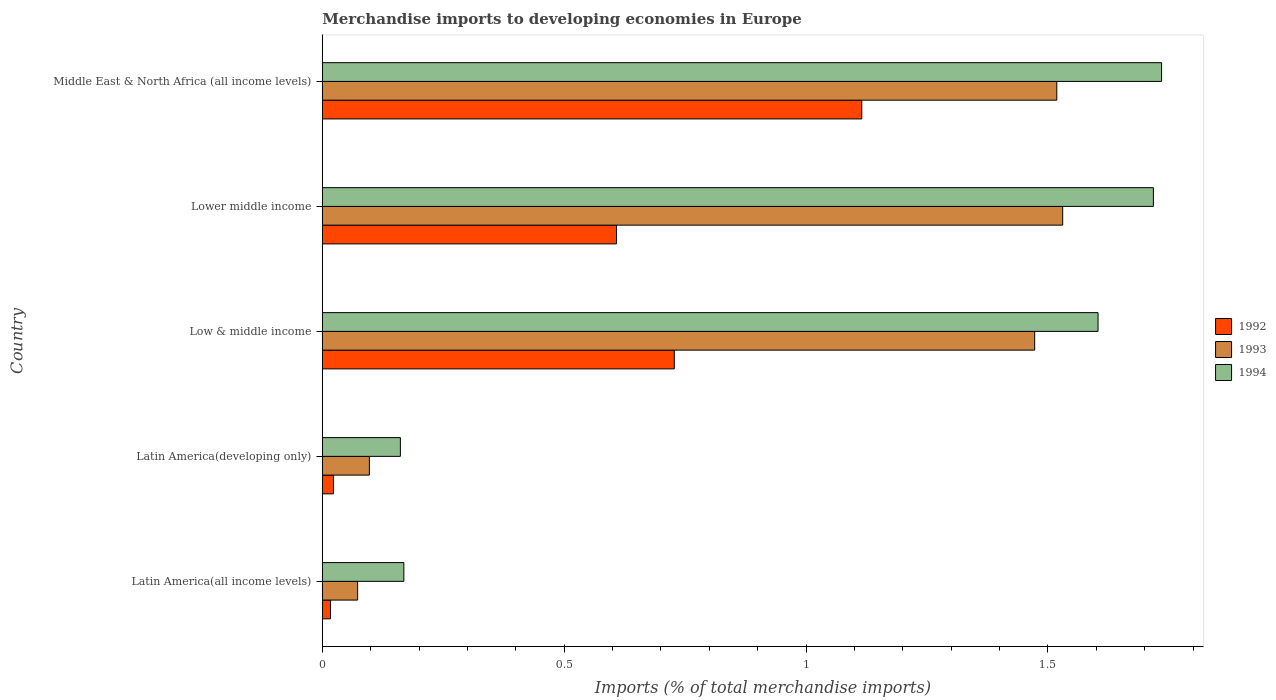How many groups of bars are there?
Ensure brevity in your answer.  5. How many bars are there on the 5th tick from the top?
Offer a terse response. 3. How many bars are there on the 1st tick from the bottom?
Make the answer very short. 3. What is the label of the 4th group of bars from the top?
Keep it short and to the point. Latin America(developing only). In how many cases, is the number of bars for a given country not equal to the number of legend labels?
Offer a very short reply. 0. What is the percentage total merchandise imports in 1994 in Low & middle income?
Give a very brief answer. 1.6. Across all countries, what is the maximum percentage total merchandise imports in 1994?
Provide a succinct answer. 1.74. Across all countries, what is the minimum percentage total merchandise imports in 1993?
Make the answer very short. 0.07. In which country was the percentage total merchandise imports in 1993 maximum?
Offer a terse response. Lower middle income. In which country was the percentage total merchandise imports in 1993 minimum?
Provide a succinct answer. Latin America(all income levels). What is the total percentage total merchandise imports in 1994 in the graph?
Give a very brief answer. 5.39. What is the difference between the percentage total merchandise imports in 1992 in Latin America(all income levels) and that in Lower middle income?
Your answer should be very brief. -0.59. What is the difference between the percentage total merchandise imports in 1994 in Latin America(all income levels) and the percentage total merchandise imports in 1993 in Latin America(developing only)?
Provide a short and direct response. 0.07. What is the average percentage total merchandise imports in 1993 per country?
Keep it short and to the point. 0.94. What is the difference between the percentage total merchandise imports in 1992 and percentage total merchandise imports in 1994 in Latin America(developing only)?
Ensure brevity in your answer.  -0.14. In how many countries, is the percentage total merchandise imports in 1993 greater than 0.6 %?
Provide a short and direct response. 3. What is the ratio of the percentage total merchandise imports in 1994 in Latin America(all income levels) to that in Lower middle income?
Keep it short and to the point. 0.1. What is the difference between the highest and the second highest percentage total merchandise imports in 1993?
Offer a very short reply. 0.01. What is the difference between the highest and the lowest percentage total merchandise imports in 1993?
Provide a succinct answer. 1.46. Is the sum of the percentage total merchandise imports in 1993 in Latin America(all income levels) and Middle East & North Africa (all income levels) greater than the maximum percentage total merchandise imports in 1994 across all countries?
Your response must be concise. No. Is it the case that in every country, the sum of the percentage total merchandise imports in 1993 and percentage total merchandise imports in 1992 is greater than the percentage total merchandise imports in 1994?
Give a very brief answer. No. Are all the bars in the graph horizontal?
Keep it short and to the point. Yes. How many countries are there in the graph?
Provide a succinct answer. 5. What is the difference between two consecutive major ticks on the X-axis?
Your response must be concise. 0.5. Does the graph contain any zero values?
Give a very brief answer. No. Does the graph contain grids?
Ensure brevity in your answer.  No. Where does the legend appear in the graph?
Give a very brief answer. Center right. How are the legend labels stacked?
Give a very brief answer. Vertical. What is the title of the graph?
Make the answer very short. Merchandise imports to developing economies in Europe. Does "2012" appear as one of the legend labels in the graph?
Your response must be concise. No. What is the label or title of the X-axis?
Your answer should be very brief. Imports (% of total merchandise imports). What is the label or title of the Y-axis?
Make the answer very short. Country. What is the Imports (% of total merchandise imports) in 1992 in Latin America(all income levels)?
Your answer should be compact. 0.02. What is the Imports (% of total merchandise imports) in 1993 in Latin America(all income levels)?
Your answer should be very brief. 0.07. What is the Imports (% of total merchandise imports) in 1994 in Latin America(all income levels)?
Provide a succinct answer. 0.17. What is the Imports (% of total merchandise imports) in 1992 in Latin America(developing only)?
Keep it short and to the point. 0.02. What is the Imports (% of total merchandise imports) of 1993 in Latin America(developing only)?
Provide a short and direct response. 0.1. What is the Imports (% of total merchandise imports) in 1994 in Latin America(developing only)?
Ensure brevity in your answer.  0.16. What is the Imports (% of total merchandise imports) in 1992 in Low & middle income?
Make the answer very short. 0.73. What is the Imports (% of total merchandise imports) of 1993 in Low & middle income?
Your answer should be very brief. 1.47. What is the Imports (% of total merchandise imports) of 1994 in Low & middle income?
Ensure brevity in your answer.  1.6. What is the Imports (% of total merchandise imports) of 1992 in Lower middle income?
Provide a succinct answer. 0.61. What is the Imports (% of total merchandise imports) in 1993 in Lower middle income?
Your answer should be compact. 1.53. What is the Imports (% of total merchandise imports) of 1994 in Lower middle income?
Keep it short and to the point. 1.72. What is the Imports (% of total merchandise imports) of 1992 in Middle East & North Africa (all income levels)?
Keep it short and to the point. 1.12. What is the Imports (% of total merchandise imports) in 1993 in Middle East & North Africa (all income levels)?
Give a very brief answer. 1.52. What is the Imports (% of total merchandise imports) of 1994 in Middle East & North Africa (all income levels)?
Provide a short and direct response. 1.74. Across all countries, what is the maximum Imports (% of total merchandise imports) in 1992?
Your answer should be compact. 1.12. Across all countries, what is the maximum Imports (% of total merchandise imports) in 1993?
Your response must be concise. 1.53. Across all countries, what is the maximum Imports (% of total merchandise imports) of 1994?
Provide a short and direct response. 1.74. Across all countries, what is the minimum Imports (% of total merchandise imports) in 1992?
Keep it short and to the point. 0.02. Across all countries, what is the minimum Imports (% of total merchandise imports) in 1993?
Give a very brief answer. 0.07. Across all countries, what is the minimum Imports (% of total merchandise imports) of 1994?
Offer a very short reply. 0.16. What is the total Imports (% of total merchandise imports) of 1992 in the graph?
Your answer should be very brief. 2.49. What is the total Imports (% of total merchandise imports) in 1993 in the graph?
Keep it short and to the point. 4.69. What is the total Imports (% of total merchandise imports) in 1994 in the graph?
Provide a succinct answer. 5.39. What is the difference between the Imports (% of total merchandise imports) in 1992 in Latin America(all income levels) and that in Latin America(developing only)?
Offer a very short reply. -0.01. What is the difference between the Imports (% of total merchandise imports) in 1993 in Latin America(all income levels) and that in Latin America(developing only)?
Offer a very short reply. -0.02. What is the difference between the Imports (% of total merchandise imports) in 1994 in Latin America(all income levels) and that in Latin America(developing only)?
Your response must be concise. 0.01. What is the difference between the Imports (% of total merchandise imports) in 1992 in Latin America(all income levels) and that in Low & middle income?
Your answer should be compact. -0.71. What is the difference between the Imports (% of total merchandise imports) in 1993 in Latin America(all income levels) and that in Low & middle income?
Provide a short and direct response. -1.4. What is the difference between the Imports (% of total merchandise imports) in 1994 in Latin America(all income levels) and that in Low & middle income?
Your response must be concise. -1.44. What is the difference between the Imports (% of total merchandise imports) of 1992 in Latin America(all income levels) and that in Lower middle income?
Your answer should be very brief. -0.59. What is the difference between the Imports (% of total merchandise imports) of 1993 in Latin America(all income levels) and that in Lower middle income?
Your answer should be compact. -1.46. What is the difference between the Imports (% of total merchandise imports) of 1994 in Latin America(all income levels) and that in Lower middle income?
Ensure brevity in your answer.  -1.55. What is the difference between the Imports (% of total merchandise imports) of 1992 in Latin America(all income levels) and that in Middle East & North Africa (all income levels)?
Provide a short and direct response. -1.1. What is the difference between the Imports (% of total merchandise imports) in 1993 in Latin America(all income levels) and that in Middle East & North Africa (all income levels)?
Offer a terse response. -1.45. What is the difference between the Imports (% of total merchandise imports) in 1994 in Latin America(all income levels) and that in Middle East & North Africa (all income levels)?
Give a very brief answer. -1.57. What is the difference between the Imports (% of total merchandise imports) in 1992 in Latin America(developing only) and that in Low & middle income?
Provide a succinct answer. -0.7. What is the difference between the Imports (% of total merchandise imports) in 1993 in Latin America(developing only) and that in Low & middle income?
Provide a short and direct response. -1.38. What is the difference between the Imports (% of total merchandise imports) in 1994 in Latin America(developing only) and that in Low & middle income?
Offer a terse response. -1.44. What is the difference between the Imports (% of total merchandise imports) in 1992 in Latin America(developing only) and that in Lower middle income?
Offer a terse response. -0.59. What is the difference between the Imports (% of total merchandise imports) of 1993 in Latin America(developing only) and that in Lower middle income?
Your answer should be very brief. -1.43. What is the difference between the Imports (% of total merchandise imports) in 1994 in Latin America(developing only) and that in Lower middle income?
Keep it short and to the point. -1.56. What is the difference between the Imports (% of total merchandise imports) of 1992 in Latin America(developing only) and that in Middle East & North Africa (all income levels)?
Your answer should be very brief. -1.09. What is the difference between the Imports (% of total merchandise imports) of 1993 in Latin America(developing only) and that in Middle East & North Africa (all income levels)?
Keep it short and to the point. -1.42. What is the difference between the Imports (% of total merchandise imports) in 1994 in Latin America(developing only) and that in Middle East & North Africa (all income levels)?
Keep it short and to the point. -1.57. What is the difference between the Imports (% of total merchandise imports) of 1992 in Low & middle income and that in Lower middle income?
Your answer should be very brief. 0.12. What is the difference between the Imports (% of total merchandise imports) of 1993 in Low & middle income and that in Lower middle income?
Keep it short and to the point. -0.06. What is the difference between the Imports (% of total merchandise imports) in 1994 in Low & middle income and that in Lower middle income?
Offer a terse response. -0.11. What is the difference between the Imports (% of total merchandise imports) of 1992 in Low & middle income and that in Middle East & North Africa (all income levels)?
Make the answer very short. -0.39. What is the difference between the Imports (% of total merchandise imports) of 1993 in Low & middle income and that in Middle East & North Africa (all income levels)?
Offer a terse response. -0.05. What is the difference between the Imports (% of total merchandise imports) in 1994 in Low & middle income and that in Middle East & North Africa (all income levels)?
Provide a succinct answer. -0.13. What is the difference between the Imports (% of total merchandise imports) of 1992 in Lower middle income and that in Middle East & North Africa (all income levels)?
Keep it short and to the point. -0.51. What is the difference between the Imports (% of total merchandise imports) of 1993 in Lower middle income and that in Middle East & North Africa (all income levels)?
Offer a terse response. 0.01. What is the difference between the Imports (% of total merchandise imports) of 1994 in Lower middle income and that in Middle East & North Africa (all income levels)?
Make the answer very short. -0.02. What is the difference between the Imports (% of total merchandise imports) of 1992 in Latin America(all income levels) and the Imports (% of total merchandise imports) of 1993 in Latin America(developing only)?
Give a very brief answer. -0.08. What is the difference between the Imports (% of total merchandise imports) in 1992 in Latin America(all income levels) and the Imports (% of total merchandise imports) in 1994 in Latin America(developing only)?
Your answer should be compact. -0.14. What is the difference between the Imports (% of total merchandise imports) of 1993 in Latin America(all income levels) and the Imports (% of total merchandise imports) of 1994 in Latin America(developing only)?
Provide a succinct answer. -0.09. What is the difference between the Imports (% of total merchandise imports) in 1992 in Latin America(all income levels) and the Imports (% of total merchandise imports) in 1993 in Low & middle income?
Your answer should be very brief. -1.46. What is the difference between the Imports (% of total merchandise imports) of 1992 in Latin America(all income levels) and the Imports (% of total merchandise imports) of 1994 in Low & middle income?
Provide a succinct answer. -1.59. What is the difference between the Imports (% of total merchandise imports) of 1993 in Latin America(all income levels) and the Imports (% of total merchandise imports) of 1994 in Low & middle income?
Offer a very short reply. -1.53. What is the difference between the Imports (% of total merchandise imports) in 1992 in Latin America(all income levels) and the Imports (% of total merchandise imports) in 1993 in Lower middle income?
Your answer should be compact. -1.51. What is the difference between the Imports (% of total merchandise imports) in 1992 in Latin America(all income levels) and the Imports (% of total merchandise imports) in 1994 in Lower middle income?
Your response must be concise. -1.7. What is the difference between the Imports (% of total merchandise imports) in 1993 in Latin America(all income levels) and the Imports (% of total merchandise imports) in 1994 in Lower middle income?
Offer a very short reply. -1.65. What is the difference between the Imports (% of total merchandise imports) of 1992 in Latin America(all income levels) and the Imports (% of total merchandise imports) of 1993 in Middle East & North Africa (all income levels)?
Give a very brief answer. -1.5. What is the difference between the Imports (% of total merchandise imports) in 1992 in Latin America(all income levels) and the Imports (% of total merchandise imports) in 1994 in Middle East & North Africa (all income levels)?
Your response must be concise. -1.72. What is the difference between the Imports (% of total merchandise imports) of 1993 in Latin America(all income levels) and the Imports (% of total merchandise imports) of 1994 in Middle East & North Africa (all income levels)?
Offer a very short reply. -1.66. What is the difference between the Imports (% of total merchandise imports) in 1992 in Latin America(developing only) and the Imports (% of total merchandise imports) in 1993 in Low & middle income?
Your answer should be very brief. -1.45. What is the difference between the Imports (% of total merchandise imports) of 1992 in Latin America(developing only) and the Imports (% of total merchandise imports) of 1994 in Low & middle income?
Your answer should be very brief. -1.58. What is the difference between the Imports (% of total merchandise imports) of 1993 in Latin America(developing only) and the Imports (% of total merchandise imports) of 1994 in Low & middle income?
Ensure brevity in your answer.  -1.51. What is the difference between the Imports (% of total merchandise imports) in 1992 in Latin America(developing only) and the Imports (% of total merchandise imports) in 1993 in Lower middle income?
Keep it short and to the point. -1.51. What is the difference between the Imports (% of total merchandise imports) of 1992 in Latin America(developing only) and the Imports (% of total merchandise imports) of 1994 in Lower middle income?
Provide a succinct answer. -1.7. What is the difference between the Imports (% of total merchandise imports) of 1993 in Latin America(developing only) and the Imports (% of total merchandise imports) of 1994 in Lower middle income?
Your answer should be very brief. -1.62. What is the difference between the Imports (% of total merchandise imports) in 1992 in Latin America(developing only) and the Imports (% of total merchandise imports) in 1993 in Middle East & North Africa (all income levels)?
Your answer should be compact. -1.5. What is the difference between the Imports (% of total merchandise imports) in 1992 in Latin America(developing only) and the Imports (% of total merchandise imports) in 1994 in Middle East & North Africa (all income levels)?
Provide a succinct answer. -1.71. What is the difference between the Imports (% of total merchandise imports) of 1993 in Latin America(developing only) and the Imports (% of total merchandise imports) of 1994 in Middle East & North Africa (all income levels)?
Keep it short and to the point. -1.64. What is the difference between the Imports (% of total merchandise imports) of 1992 in Low & middle income and the Imports (% of total merchandise imports) of 1993 in Lower middle income?
Your answer should be very brief. -0.8. What is the difference between the Imports (% of total merchandise imports) of 1992 in Low & middle income and the Imports (% of total merchandise imports) of 1994 in Lower middle income?
Your answer should be very brief. -0.99. What is the difference between the Imports (% of total merchandise imports) in 1993 in Low & middle income and the Imports (% of total merchandise imports) in 1994 in Lower middle income?
Offer a very short reply. -0.25. What is the difference between the Imports (% of total merchandise imports) in 1992 in Low & middle income and the Imports (% of total merchandise imports) in 1993 in Middle East & North Africa (all income levels)?
Offer a terse response. -0.79. What is the difference between the Imports (% of total merchandise imports) of 1992 in Low & middle income and the Imports (% of total merchandise imports) of 1994 in Middle East & North Africa (all income levels)?
Offer a terse response. -1.01. What is the difference between the Imports (% of total merchandise imports) in 1993 in Low & middle income and the Imports (% of total merchandise imports) in 1994 in Middle East & North Africa (all income levels)?
Give a very brief answer. -0.26. What is the difference between the Imports (% of total merchandise imports) of 1992 in Lower middle income and the Imports (% of total merchandise imports) of 1993 in Middle East & North Africa (all income levels)?
Your response must be concise. -0.91. What is the difference between the Imports (% of total merchandise imports) of 1992 in Lower middle income and the Imports (% of total merchandise imports) of 1994 in Middle East & North Africa (all income levels)?
Offer a very short reply. -1.13. What is the difference between the Imports (% of total merchandise imports) of 1993 in Lower middle income and the Imports (% of total merchandise imports) of 1994 in Middle East & North Africa (all income levels)?
Provide a succinct answer. -0.2. What is the average Imports (% of total merchandise imports) in 1992 per country?
Offer a very short reply. 0.5. What is the average Imports (% of total merchandise imports) in 1993 per country?
Your answer should be very brief. 0.94. What is the average Imports (% of total merchandise imports) in 1994 per country?
Make the answer very short. 1.08. What is the difference between the Imports (% of total merchandise imports) in 1992 and Imports (% of total merchandise imports) in 1993 in Latin America(all income levels)?
Your answer should be very brief. -0.06. What is the difference between the Imports (% of total merchandise imports) in 1992 and Imports (% of total merchandise imports) in 1994 in Latin America(all income levels)?
Give a very brief answer. -0.15. What is the difference between the Imports (% of total merchandise imports) in 1993 and Imports (% of total merchandise imports) in 1994 in Latin America(all income levels)?
Your answer should be compact. -0.1. What is the difference between the Imports (% of total merchandise imports) in 1992 and Imports (% of total merchandise imports) in 1993 in Latin America(developing only)?
Provide a succinct answer. -0.07. What is the difference between the Imports (% of total merchandise imports) in 1992 and Imports (% of total merchandise imports) in 1994 in Latin America(developing only)?
Your response must be concise. -0.14. What is the difference between the Imports (% of total merchandise imports) of 1993 and Imports (% of total merchandise imports) of 1994 in Latin America(developing only)?
Keep it short and to the point. -0.06. What is the difference between the Imports (% of total merchandise imports) of 1992 and Imports (% of total merchandise imports) of 1993 in Low & middle income?
Your answer should be compact. -0.74. What is the difference between the Imports (% of total merchandise imports) in 1992 and Imports (% of total merchandise imports) in 1994 in Low & middle income?
Give a very brief answer. -0.88. What is the difference between the Imports (% of total merchandise imports) of 1993 and Imports (% of total merchandise imports) of 1994 in Low & middle income?
Keep it short and to the point. -0.13. What is the difference between the Imports (% of total merchandise imports) of 1992 and Imports (% of total merchandise imports) of 1993 in Lower middle income?
Offer a very short reply. -0.92. What is the difference between the Imports (% of total merchandise imports) of 1992 and Imports (% of total merchandise imports) of 1994 in Lower middle income?
Your answer should be compact. -1.11. What is the difference between the Imports (% of total merchandise imports) in 1993 and Imports (% of total merchandise imports) in 1994 in Lower middle income?
Your response must be concise. -0.19. What is the difference between the Imports (% of total merchandise imports) of 1992 and Imports (% of total merchandise imports) of 1993 in Middle East & North Africa (all income levels)?
Your answer should be very brief. -0.4. What is the difference between the Imports (% of total merchandise imports) of 1992 and Imports (% of total merchandise imports) of 1994 in Middle East & North Africa (all income levels)?
Offer a very short reply. -0.62. What is the difference between the Imports (% of total merchandise imports) in 1993 and Imports (% of total merchandise imports) in 1994 in Middle East & North Africa (all income levels)?
Provide a short and direct response. -0.22. What is the ratio of the Imports (% of total merchandise imports) in 1992 in Latin America(all income levels) to that in Latin America(developing only)?
Provide a succinct answer. 0.73. What is the ratio of the Imports (% of total merchandise imports) in 1993 in Latin America(all income levels) to that in Latin America(developing only)?
Your answer should be compact. 0.75. What is the ratio of the Imports (% of total merchandise imports) of 1994 in Latin America(all income levels) to that in Latin America(developing only)?
Give a very brief answer. 1.04. What is the ratio of the Imports (% of total merchandise imports) of 1992 in Latin America(all income levels) to that in Low & middle income?
Keep it short and to the point. 0.02. What is the ratio of the Imports (% of total merchandise imports) of 1993 in Latin America(all income levels) to that in Low & middle income?
Give a very brief answer. 0.05. What is the ratio of the Imports (% of total merchandise imports) of 1994 in Latin America(all income levels) to that in Low & middle income?
Provide a short and direct response. 0.11. What is the ratio of the Imports (% of total merchandise imports) of 1992 in Latin America(all income levels) to that in Lower middle income?
Offer a terse response. 0.03. What is the ratio of the Imports (% of total merchandise imports) in 1993 in Latin America(all income levels) to that in Lower middle income?
Provide a succinct answer. 0.05. What is the ratio of the Imports (% of total merchandise imports) in 1994 in Latin America(all income levels) to that in Lower middle income?
Keep it short and to the point. 0.1. What is the ratio of the Imports (% of total merchandise imports) in 1992 in Latin America(all income levels) to that in Middle East & North Africa (all income levels)?
Provide a succinct answer. 0.02. What is the ratio of the Imports (% of total merchandise imports) in 1993 in Latin America(all income levels) to that in Middle East & North Africa (all income levels)?
Your answer should be very brief. 0.05. What is the ratio of the Imports (% of total merchandise imports) in 1994 in Latin America(all income levels) to that in Middle East & North Africa (all income levels)?
Give a very brief answer. 0.1. What is the ratio of the Imports (% of total merchandise imports) in 1992 in Latin America(developing only) to that in Low & middle income?
Provide a short and direct response. 0.03. What is the ratio of the Imports (% of total merchandise imports) in 1993 in Latin America(developing only) to that in Low & middle income?
Offer a terse response. 0.07. What is the ratio of the Imports (% of total merchandise imports) of 1994 in Latin America(developing only) to that in Low & middle income?
Make the answer very short. 0.1. What is the ratio of the Imports (% of total merchandise imports) of 1992 in Latin America(developing only) to that in Lower middle income?
Provide a short and direct response. 0.04. What is the ratio of the Imports (% of total merchandise imports) in 1993 in Latin America(developing only) to that in Lower middle income?
Give a very brief answer. 0.06. What is the ratio of the Imports (% of total merchandise imports) in 1994 in Latin America(developing only) to that in Lower middle income?
Your response must be concise. 0.09. What is the ratio of the Imports (% of total merchandise imports) of 1992 in Latin America(developing only) to that in Middle East & North Africa (all income levels)?
Your answer should be compact. 0.02. What is the ratio of the Imports (% of total merchandise imports) of 1993 in Latin America(developing only) to that in Middle East & North Africa (all income levels)?
Offer a terse response. 0.06. What is the ratio of the Imports (% of total merchandise imports) of 1994 in Latin America(developing only) to that in Middle East & North Africa (all income levels)?
Offer a terse response. 0.09. What is the ratio of the Imports (% of total merchandise imports) of 1992 in Low & middle income to that in Lower middle income?
Your answer should be very brief. 1.2. What is the ratio of the Imports (% of total merchandise imports) in 1993 in Low & middle income to that in Lower middle income?
Offer a terse response. 0.96. What is the ratio of the Imports (% of total merchandise imports) of 1994 in Low & middle income to that in Lower middle income?
Provide a succinct answer. 0.93. What is the ratio of the Imports (% of total merchandise imports) in 1992 in Low & middle income to that in Middle East & North Africa (all income levels)?
Your response must be concise. 0.65. What is the ratio of the Imports (% of total merchandise imports) of 1993 in Low & middle income to that in Middle East & North Africa (all income levels)?
Offer a very short reply. 0.97. What is the ratio of the Imports (% of total merchandise imports) of 1994 in Low & middle income to that in Middle East & North Africa (all income levels)?
Offer a very short reply. 0.92. What is the ratio of the Imports (% of total merchandise imports) in 1992 in Lower middle income to that in Middle East & North Africa (all income levels)?
Provide a short and direct response. 0.55. What is the ratio of the Imports (% of total merchandise imports) of 1994 in Lower middle income to that in Middle East & North Africa (all income levels)?
Provide a short and direct response. 0.99. What is the difference between the highest and the second highest Imports (% of total merchandise imports) of 1992?
Your response must be concise. 0.39. What is the difference between the highest and the second highest Imports (% of total merchandise imports) of 1993?
Your response must be concise. 0.01. What is the difference between the highest and the second highest Imports (% of total merchandise imports) in 1994?
Make the answer very short. 0.02. What is the difference between the highest and the lowest Imports (% of total merchandise imports) in 1992?
Offer a terse response. 1.1. What is the difference between the highest and the lowest Imports (% of total merchandise imports) in 1993?
Make the answer very short. 1.46. What is the difference between the highest and the lowest Imports (% of total merchandise imports) of 1994?
Your answer should be very brief. 1.57. 